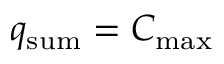Convert formula to latex. <formula><loc_0><loc_0><loc_500><loc_500>q _ { s u m } = C _ { \max }</formula> 